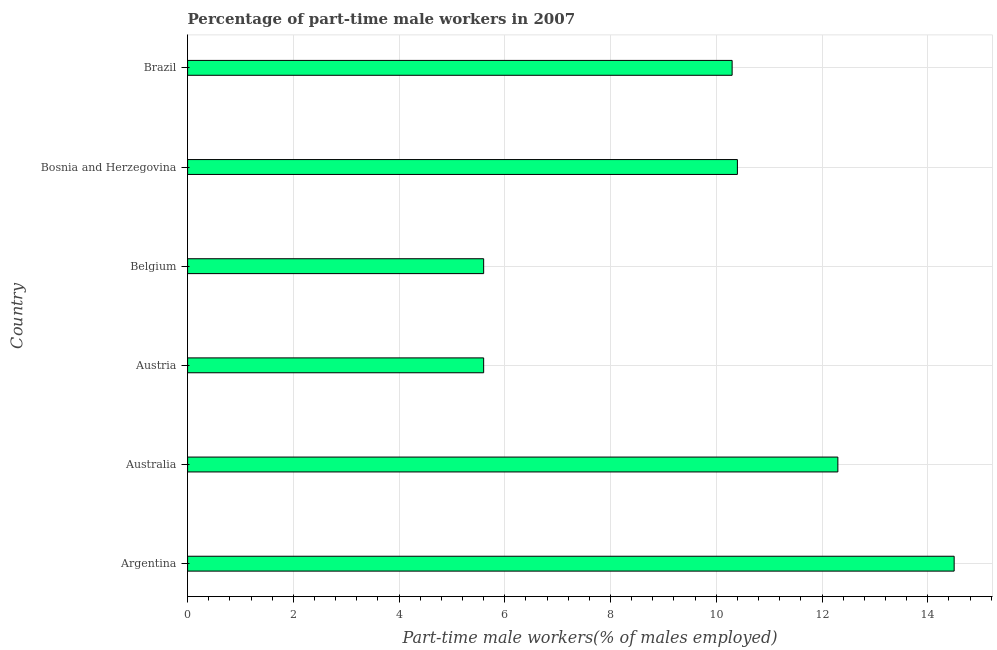Does the graph contain any zero values?
Keep it short and to the point. No. What is the title of the graph?
Make the answer very short. Percentage of part-time male workers in 2007. What is the label or title of the X-axis?
Give a very brief answer. Part-time male workers(% of males employed). What is the percentage of part-time male workers in Belgium?
Make the answer very short. 5.6. Across all countries, what is the minimum percentage of part-time male workers?
Offer a very short reply. 5.6. In which country was the percentage of part-time male workers maximum?
Provide a succinct answer. Argentina. In which country was the percentage of part-time male workers minimum?
Provide a succinct answer. Austria. What is the sum of the percentage of part-time male workers?
Provide a succinct answer. 58.7. What is the average percentage of part-time male workers per country?
Offer a very short reply. 9.78. What is the median percentage of part-time male workers?
Give a very brief answer. 10.35. In how many countries, is the percentage of part-time male workers greater than 7.2 %?
Offer a terse response. 4. What is the ratio of the percentage of part-time male workers in Austria to that in Bosnia and Herzegovina?
Provide a succinct answer. 0.54. Is the percentage of part-time male workers in Austria less than that in Brazil?
Offer a terse response. Yes. What is the difference between the highest and the second highest percentage of part-time male workers?
Give a very brief answer. 2.2. What is the difference between the highest and the lowest percentage of part-time male workers?
Your response must be concise. 8.9. Are all the bars in the graph horizontal?
Ensure brevity in your answer.  Yes. How many countries are there in the graph?
Offer a very short reply. 6. What is the difference between two consecutive major ticks on the X-axis?
Give a very brief answer. 2. What is the Part-time male workers(% of males employed) in Argentina?
Your answer should be very brief. 14.5. What is the Part-time male workers(% of males employed) in Australia?
Provide a succinct answer. 12.3. What is the Part-time male workers(% of males employed) of Austria?
Your response must be concise. 5.6. What is the Part-time male workers(% of males employed) of Belgium?
Give a very brief answer. 5.6. What is the Part-time male workers(% of males employed) of Bosnia and Herzegovina?
Give a very brief answer. 10.4. What is the Part-time male workers(% of males employed) in Brazil?
Make the answer very short. 10.3. What is the difference between the Part-time male workers(% of males employed) in Argentina and Australia?
Your answer should be very brief. 2.2. What is the difference between the Part-time male workers(% of males employed) in Argentina and Austria?
Ensure brevity in your answer.  8.9. What is the difference between the Part-time male workers(% of males employed) in Argentina and Belgium?
Give a very brief answer. 8.9. What is the difference between the Part-time male workers(% of males employed) in Argentina and Bosnia and Herzegovina?
Provide a succinct answer. 4.1. What is the difference between the Part-time male workers(% of males employed) in Australia and Austria?
Your response must be concise. 6.7. What is the difference between the Part-time male workers(% of males employed) in Austria and Brazil?
Keep it short and to the point. -4.7. What is the difference between the Part-time male workers(% of males employed) in Belgium and Brazil?
Your answer should be very brief. -4.7. What is the difference between the Part-time male workers(% of males employed) in Bosnia and Herzegovina and Brazil?
Provide a succinct answer. 0.1. What is the ratio of the Part-time male workers(% of males employed) in Argentina to that in Australia?
Ensure brevity in your answer.  1.18. What is the ratio of the Part-time male workers(% of males employed) in Argentina to that in Austria?
Give a very brief answer. 2.59. What is the ratio of the Part-time male workers(% of males employed) in Argentina to that in Belgium?
Offer a very short reply. 2.59. What is the ratio of the Part-time male workers(% of males employed) in Argentina to that in Bosnia and Herzegovina?
Make the answer very short. 1.39. What is the ratio of the Part-time male workers(% of males employed) in Argentina to that in Brazil?
Provide a short and direct response. 1.41. What is the ratio of the Part-time male workers(% of males employed) in Australia to that in Austria?
Give a very brief answer. 2.2. What is the ratio of the Part-time male workers(% of males employed) in Australia to that in Belgium?
Your answer should be very brief. 2.2. What is the ratio of the Part-time male workers(% of males employed) in Australia to that in Bosnia and Herzegovina?
Your response must be concise. 1.18. What is the ratio of the Part-time male workers(% of males employed) in Australia to that in Brazil?
Make the answer very short. 1.19. What is the ratio of the Part-time male workers(% of males employed) in Austria to that in Bosnia and Herzegovina?
Offer a terse response. 0.54. What is the ratio of the Part-time male workers(% of males employed) in Austria to that in Brazil?
Provide a succinct answer. 0.54. What is the ratio of the Part-time male workers(% of males employed) in Belgium to that in Bosnia and Herzegovina?
Your answer should be very brief. 0.54. What is the ratio of the Part-time male workers(% of males employed) in Belgium to that in Brazil?
Your answer should be very brief. 0.54. 